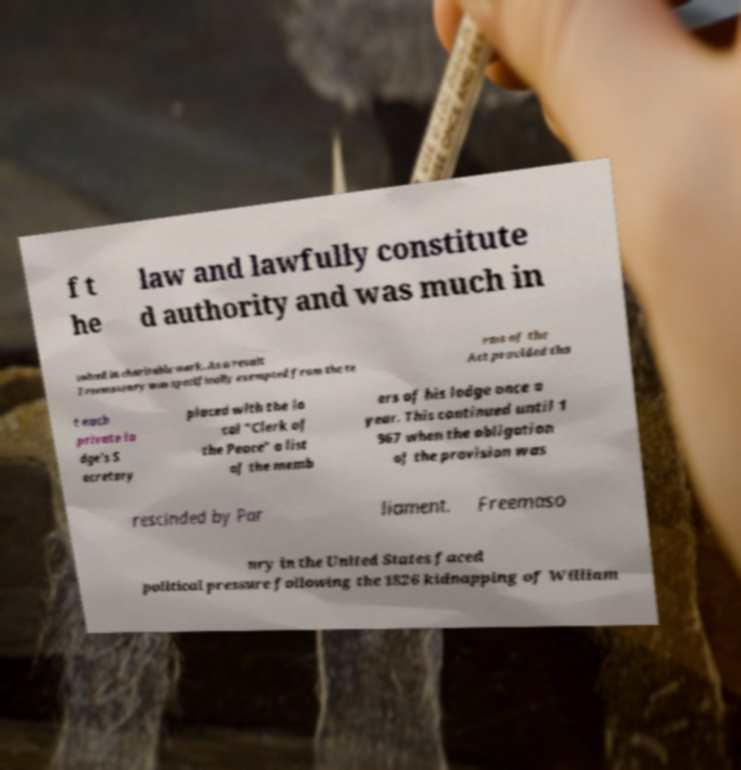Could you assist in decoding the text presented in this image and type it out clearly? f t he law and lawfully constitute d authority and was much in volved in charitable work. As a result Freemasonry was specifically exempted from the te rms of the Act provided tha t each private lo dge's S ecretary placed with the lo cal "Clerk of the Peace" a list of the memb ers of his lodge once a year. This continued until 1 967 when the obligation of the provision was rescinded by Par liament. Freemaso nry in the United States faced political pressure following the 1826 kidnapping of William 